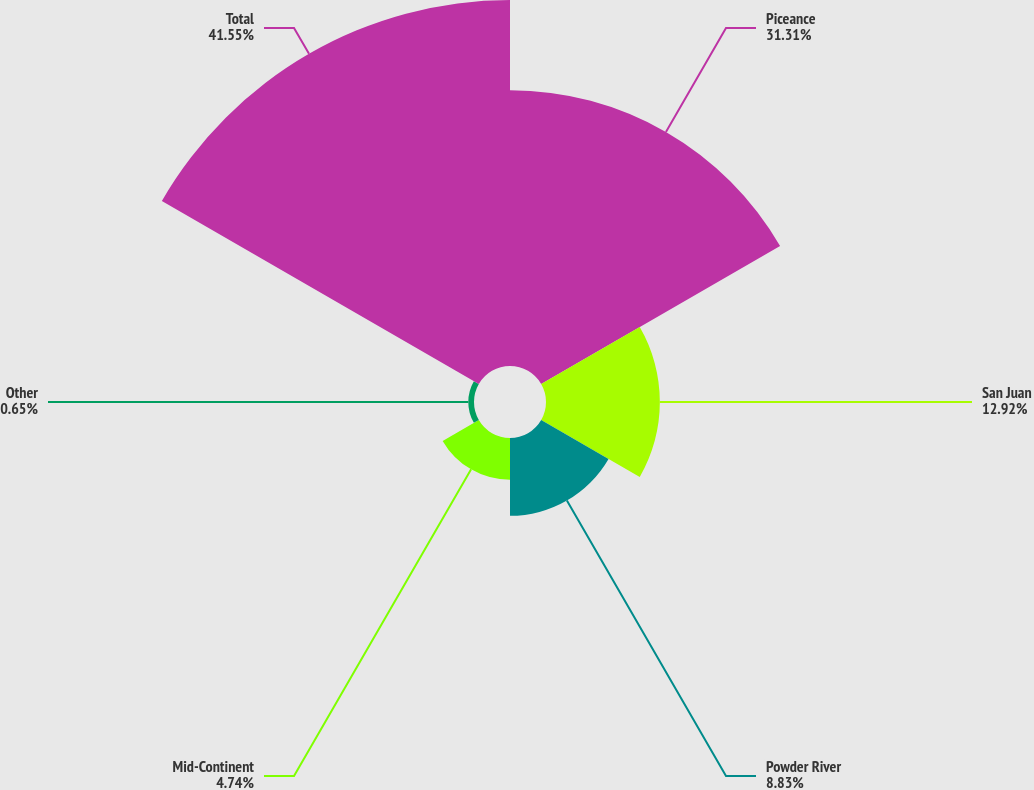Convert chart to OTSL. <chart><loc_0><loc_0><loc_500><loc_500><pie_chart><fcel>Piceance<fcel>San Juan<fcel>Powder River<fcel>Mid-Continent<fcel>Other<fcel>Total<nl><fcel>31.31%<fcel>12.92%<fcel>8.83%<fcel>4.74%<fcel>0.65%<fcel>41.54%<nl></chart> 